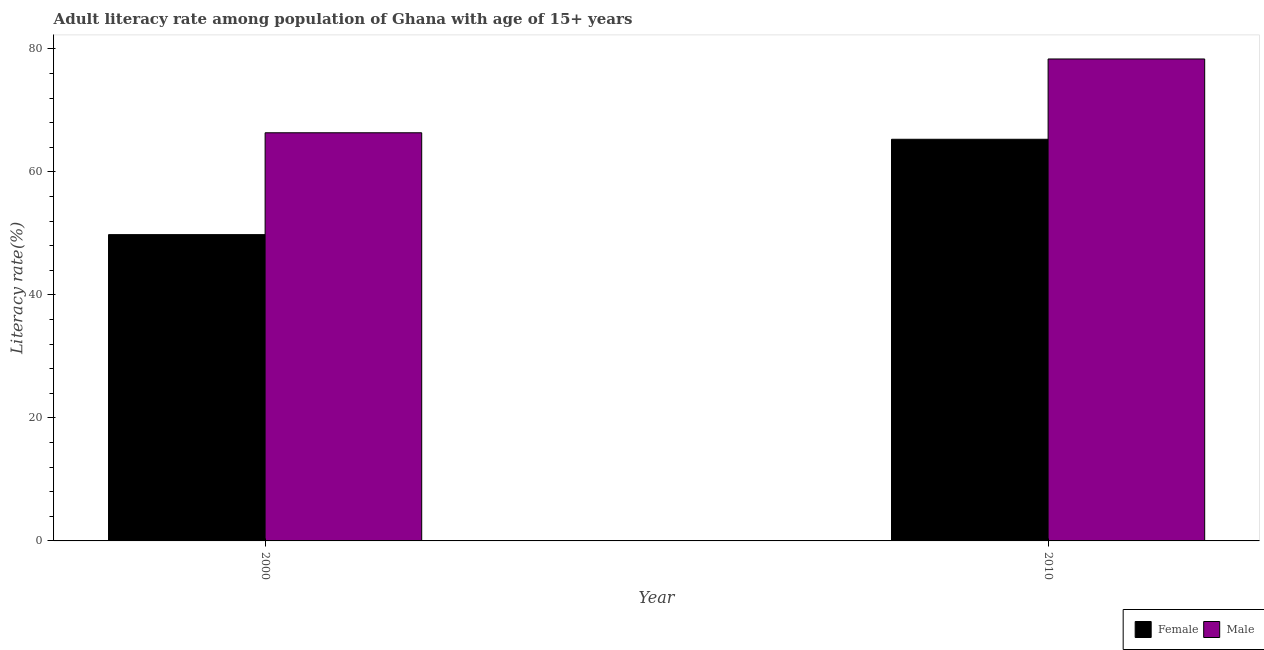Are the number of bars on each tick of the X-axis equal?
Offer a terse response. Yes. What is the label of the 2nd group of bars from the left?
Provide a succinct answer. 2010. What is the female adult literacy rate in 2000?
Your answer should be compact. 49.79. Across all years, what is the maximum female adult literacy rate?
Provide a short and direct response. 65.29. Across all years, what is the minimum male adult literacy rate?
Provide a succinct answer. 66.35. In which year was the female adult literacy rate maximum?
Provide a succinct answer. 2010. In which year was the female adult literacy rate minimum?
Give a very brief answer. 2000. What is the total male adult literacy rate in the graph?
Offer a very short reply. 144.7. What is the difference between the female adult literacy rate in 2000 and that in 2010?
Keep it short and to the point. -15.5. What is the difference between the female adult literacy rate in 2010 and the male adult literacy rate in 2000?
Provide a succinct answer. 15.5. What is the average female adult literacy rate per year?
Make the answer very short. 57.54. In how many years, is the male adult literacy rate greater than 12 %?
Provide a short and direct response. 2. What is the ratio of the male adult literacy rate in 2000 to that in 2010?
Your response must be concise. 0.85. Is the female adult literacy rate in 2000 less than that in 2010?
Provide a succinct answer. Yes. What does the 1st bar from the right in 2010 represents?
Your response must be concise. Male. How many bars are there?
Your response must be concise. 4. How many years are there in the graph?
Your answer should be compact. 2. Where does the legend appear in the graph?
Your answer should be very brief. Bottom right. What is the title of the graph?
Give a very brief answer. Adult literacy rate among population of Ghana with age of 15+ years. Does "Goods" appear as one of the legend labels in the graph?
Make the answer very short. No. What is the label or title of the Y-axis?
Offer a very short reply. Literacy rate(%). What is the Literacy rate(%) of Female in 2000?
Your response must be concise. 49.79. What is the Literacy rate(%) in Male in 2000?
Offer a terse response. 66.35. What is the Literacy rate(%) in Female in 2010?
Your answer should be very brief. 65.29. What is the Literacy rate(%) of Male in 2010?
Your answer should be very brief. 78.35. Across all years, what is the maximum Literacy rate(%) in Female?
Provide a short and direct response. 65.29. Across all years, what is the maximum Literacy rate(%) in Male?
Your response must be concise. 78.35. Across all years, what is the minimum Literacy rate(%) of Female?
Your response must be concise. 49.79. Across all years, what is the minimum Literacy rate(%) in Male?
Offer a terse response. 66.35. What is the total Literacy rate(%) in Female in the graph?
Your response must be concise. 115.09. What is the total Literacy rate(%) of Male in the graph?
Your answer should be very brief. 144.7. What is the difference between the Literacy rate(%) in Female in 2000 and that in 2010?
Make the answer very short. -15.5. What is the difference between the Literacy rate(%) in Male in 2000 and that in 2010?
Give a very brief answer. -12. What is the difference between the Literacy rate(%) of Female in 2000 and the Literacy rate(%) of Male in 2010?
Offer a very short reply. -28.56. What is the average Literacy rate(%) of Female per year?
Your answer should be compact. 57.54. What is the average Literacy rate(%) in Male per year?
Provide a short and direct response. 72.35. In the year 2000, what is the difference between the Literacy rate(%) in Female and Literacy rate(%) in Male?
Make the answer very short. -16.56. In the year 2010, what is the difference between the Literacy rate(%) of Female and Literacy rate(%) of Male?
Offer a very short reply. -13.05. What is the ratio of the Literacy rate(%) in Female in 2000 to that in 2010?
Your response must be concise. 0.76. What is the ratio of the Literacy rate(%) in Male in 2000 to that in 2010?
Keep it short and to the point. 0.85. What is the difference between the highest and the second highest Literacy rate(%) in Female?
Ensure brevity in your answer.  15.5. What is the difference between the highest and the second highest Literacy rate(%) in Male?
Your answer should be very brief. 12. What is the difference between the highest and the lowest Literacy rate(%) in Female?
Offer a very short reply. 15.5. What is the difference between the highest and the lowest Literacy rate(%) of Male?
Offer a very short reply. 12. 